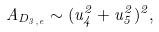<formula> <loc_0><loc_0><loc_500><loc_500>A _ { D _ { 3 , e } } \sim ( u _ { 4 } ^ { 2 } + u _ { 5 } ^ { 2 } ) ^ { 2 } ,</formula> 